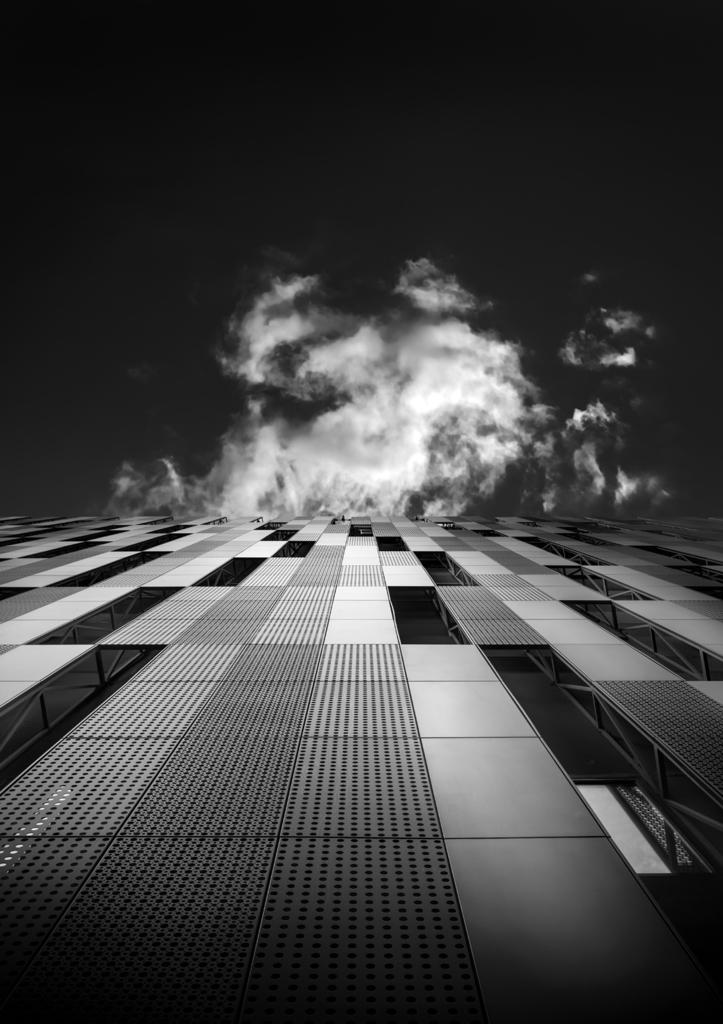What can be seen in the sky in the image? There are clouds in the image. What type of material is used for the rods in the image? The rods in the image are made of metal. What type of structure is depicted in the image? The image appears to depict a building. What is the color scheme of the image? The photography is in black and white. Where is the rabbit hiding in the image? There is no rabbit present in the image. What type of soap is being used to clean the lamp in the image? There is no soap or lamp present in the image. 